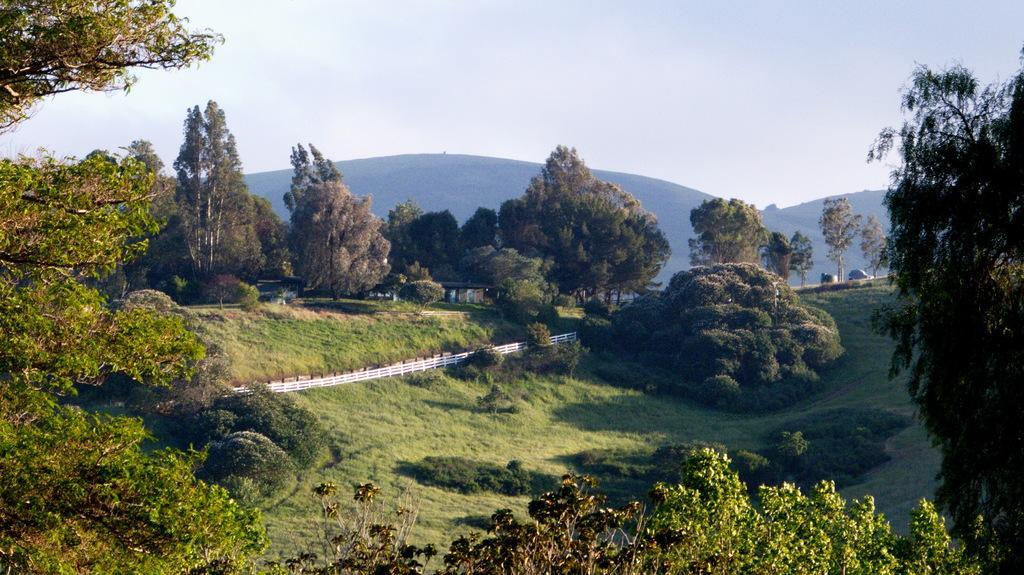In one or two sentences, can you explain what this image depicts? In this image we can see there are many trees surrounded by grass and the background is the sky. 